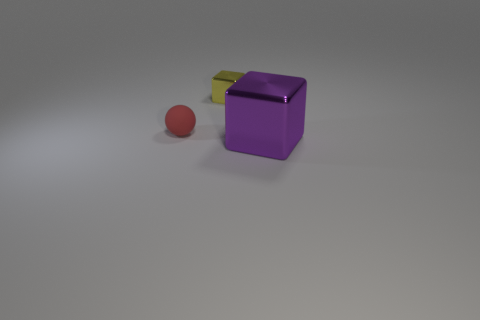Are there any other things that are the same material as the small red thing?
Provide a succinct answer. No. Is there any other thing that has the same shape as the red rubber object?
Your answer should be compact. No. Does the block behind the big metallic block have the same material as the sphere?
Provide a succinct answer. No. What is the color of the thing that is right of the small matte object and in front of the small yellow metal block?
Keep it short and to the point. Purple. What number of small things are in front of the small object that is in front of the small shiny block?
Provide a short and direct response. 0. The tiny matte thing has what color?
Provide a short and direct response. Red. How many things are large blue things or small objects?
Keep it short and to the point. 2. There is a small thing on the right side of the object to the left of the tiny metallic thing; what shape is it?
Give a very brief answer. Cube. How many other objects are the same material as the red thing?
Give a very brief answer. 0. Is the small yellow object made of the same material as the block in front of the red sphere?
Offer a terse response. Yes. 